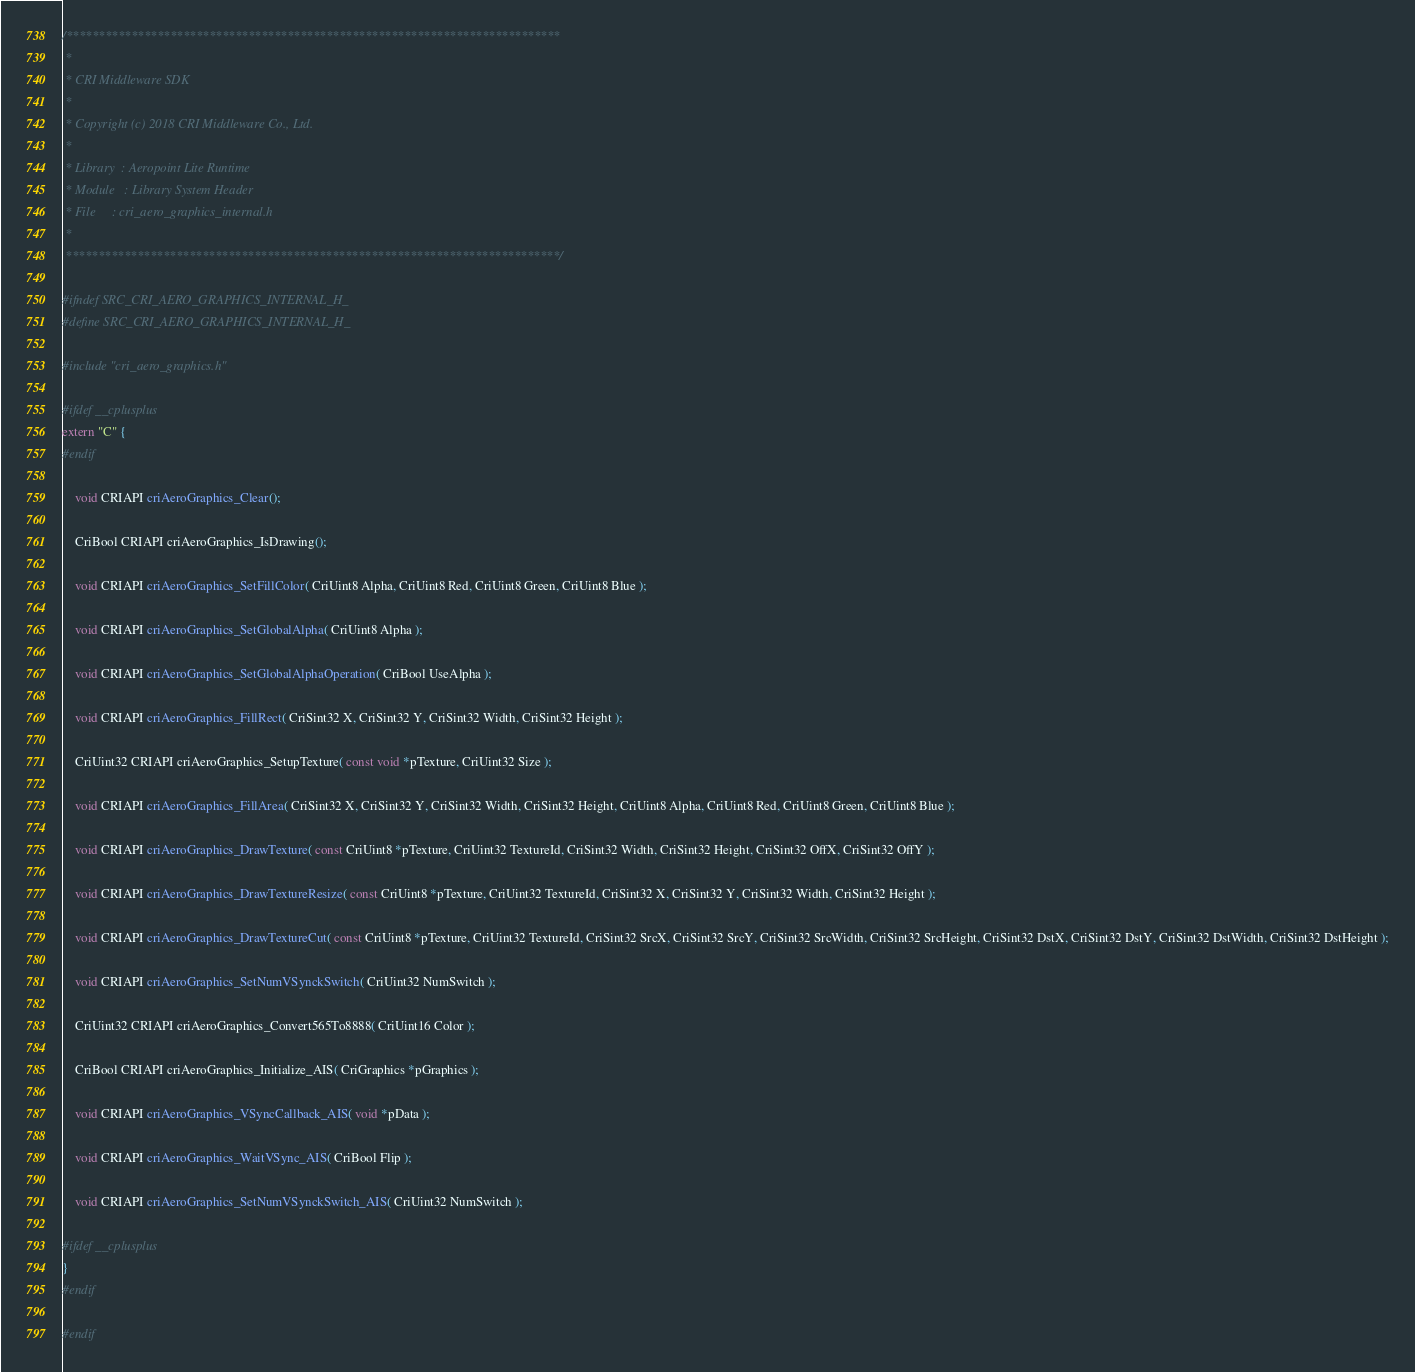Convert code to text. <code><loc_0><loc_0><loc_500><loc_500><_C_>/****************************************************************************
 *
 * CRI Middleware SDK
 *
 * Copyright (c) 2018 CRI Middleware Co., Ltd.
 *
 * Library  : Aeropoint Lite Runtime
 * Module   : Library System Header
 * File     : cri_aero_graphics_internal.h
 *
 ****************************************************************************/

#ifndef SRC_CRI_AERO_GRAPHICS_INTERNAL_H_
#define SRC_CRI_AERO_GRAPHICS_INTERNAL_H_

#include "cri_aero_graphics.h"

#ifdef __cplusplus
extern "C" {
#endif

	void CRIAPI criAeroGraphics_Clear();

	CriBool CRIAPI criAeroGraphics_IsDrawing();

	void CRIAPI criAeroGraphics_SetFillColor( CriUint8 Alpha, CriUint8 Red, CriUint8 Green, CriUint8 Blue );

	void CRIAPI criAeroGraphics_SetGlobalAlpha( CriUint8 Alpha );

	void CRIAPI criAeroGraphics_SetGlobalAlphaOperation( CriBool UseAlpha );

	void CRIAPI criAeroGraphics_FillRect( CriSint32 X, CriSint32 Y, CriSint32 Width, CriSint32 Height );

	CriUint32 CRIAPI criAeroGraphics_SetupTexture( const void *pTexture, CriUint32 Size );

	void CRIAPI criAeroGraphics_FillArea( CriSint32 X, CriSint32 Y, CriSint32 Width, CriSint32 Height, CriUint8 Alpha, CriUint8 Red, CriUint8 Green, CriUint8 Blue );

	void CRIAPI criAeroGraphics_DrawTexture( const CriUint8 *pTexture, CriUint32 TextureId, CriSint32 Width, CriSint32 Height, CriSint32 OffX, CriSint32 OffY );

	void CRIAPI criAeroGraphics_DrawTextureResize( const CriUint8 *pTexture, CriUint32 TextureId, CriSint32 X, CriSint32 Y, CriSint32 Width, CriSint32 Height );

	void CRIAPI criAeroGraphics_DrawTextureCut( const CriUint8 *pTexture, CriUint32 TextureId, CriSint32 SrcX, CriSint32 SrcY, CriSint32 SrcWidth, CriSint32 SrcHeight, CriSint32 DstX, CriSint32 DstY, CriSint32 DstWidth, CriSint32 DstHeight );

	void CRIAPI criAeroGraphics_SetNumVSynckSwitch( CriUint32 NumSwitch );

	CriUint32 CRIAPI criAeroGraphics_Convert565To8888( CriUint16 Color );

	CriBool CRIAPI criAeroGraphics_Initialize_AIS( CriGraphics *pGraphics );

	void CRIAPI criAeroGraphics_VSyncCallback_AIS( void *pData );

	void CRIAPI criAeroGraphics_WaitVSync_AIS( CriBool Flip );

	void CRIAPI criAeroGraphics_SetNumVSynckSwitch_AIS( CriUint32 NumSwitch );

#ifdef __cplusplus
}
#endif

#endif 
</code> 